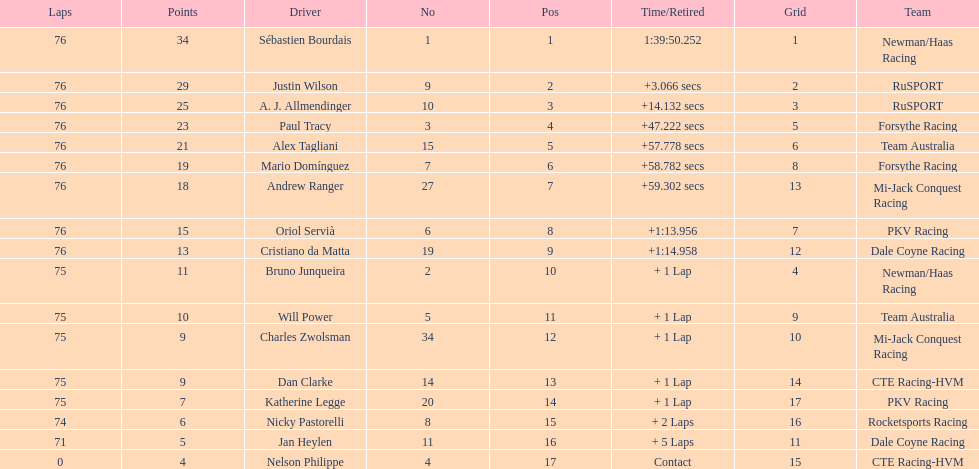How many positions are held by canada? 3. 